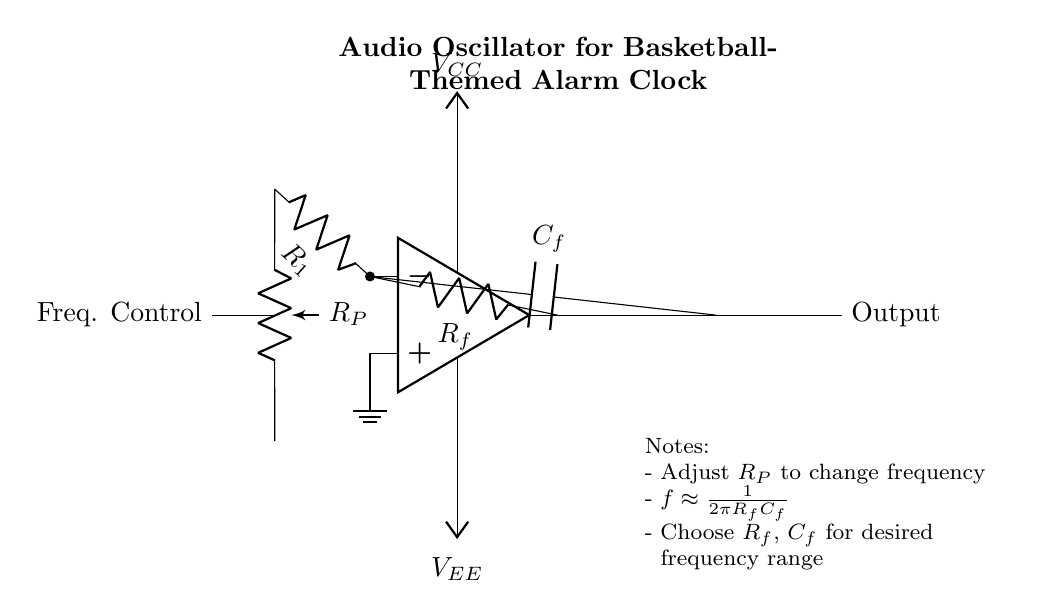What type of circuit is depicted? The circuit shown is an audio oscillator circuit, specifically designed to generate sound, indicated by the presence of components like the op-amp, resistors, and capacitors.
Answer: Audio oscillator What is the purpose of the potentiometer? The potentiometer, labeled as R_P, is used for frequency control, allowing the user to adjust the frequency at which the oscillator operates, thereby altering the sound it produces.
Answer: Frequency control How many capacitors are in the circuit? There is one capacitor in the circuit, labeled as C_f, which is part of the feedback loop of the operational amplifier.
Answer: One What determines the frequency of the output sound? The frequency of the output sound is determined by the values of the feedback resistor R_f and the capacitor C_f, according to the relationship given in the notes: frequency is approximately inversely proportional to the product of these two components.
Answer: R_f and C_f What is the power supply voltage labeled as? The power supply voltages are labeled as V_CC and V_EE, where V_CC is the positive supply voltage connected to the op-amp, and V_EE is the negative supply voltage.
Answer: V_CC and V_EE 